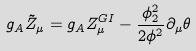Convert formula to latex. <formula><loc_0><loc_0><loc_500><loc_500>g _ { A } \tilde { Z } _ { \mu } = g _ { A } Z _ { \mu } ^ { G I } - { \frac { \phi _ { 2 } ^ { 2 } } { 2 \phi ^ { 2 } } } \partial _ { \mu } \theta</formula> 